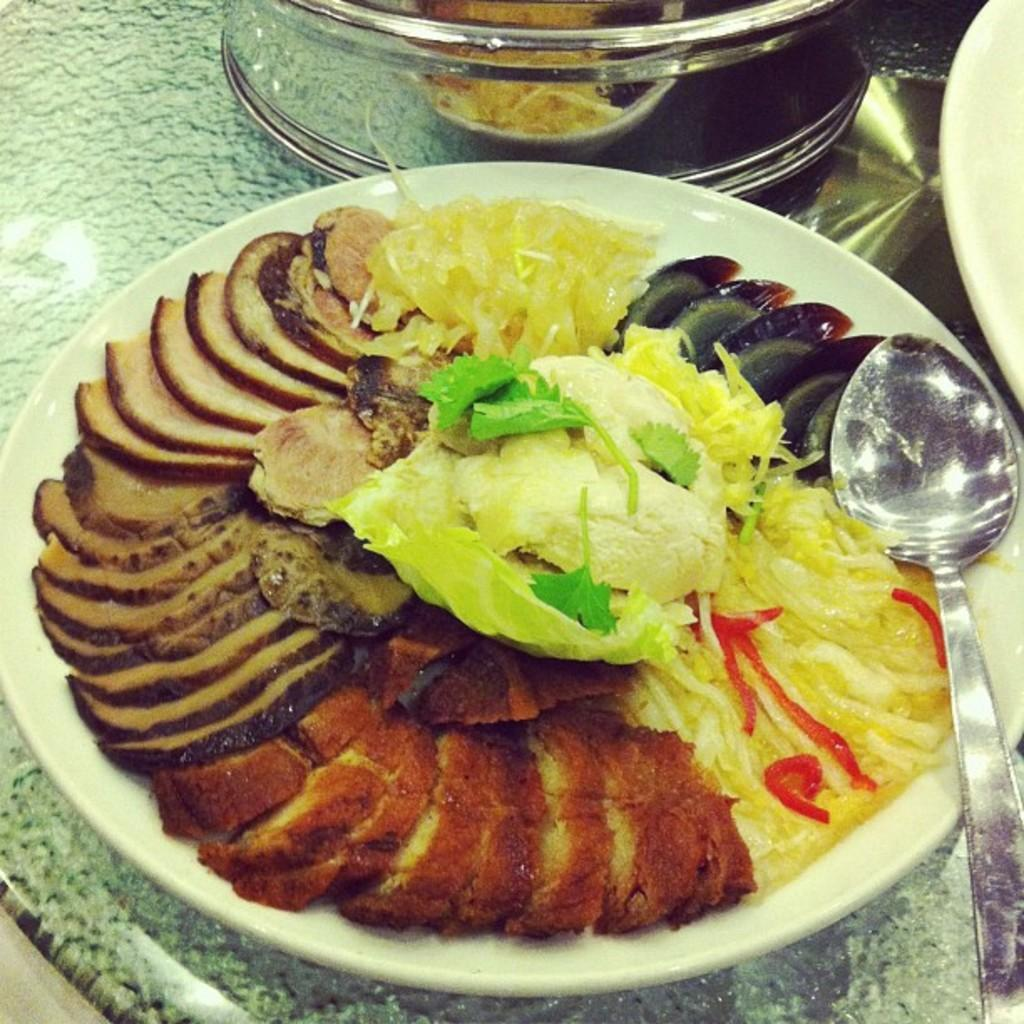What is the main subject of the image? The main subject of the image is a close-up of food items on a white plate. What utensil can be seen in the image? There is a spoon visible in the image. What type of container is present on the surface in the image? There is a glass vessel on the surface in the image. How does the pail help in the rainstorm depicted in the image? There is no rainstorm or pail present in the image; it is a close-up of food items on a white plate with a spoon and a glass vessel. 